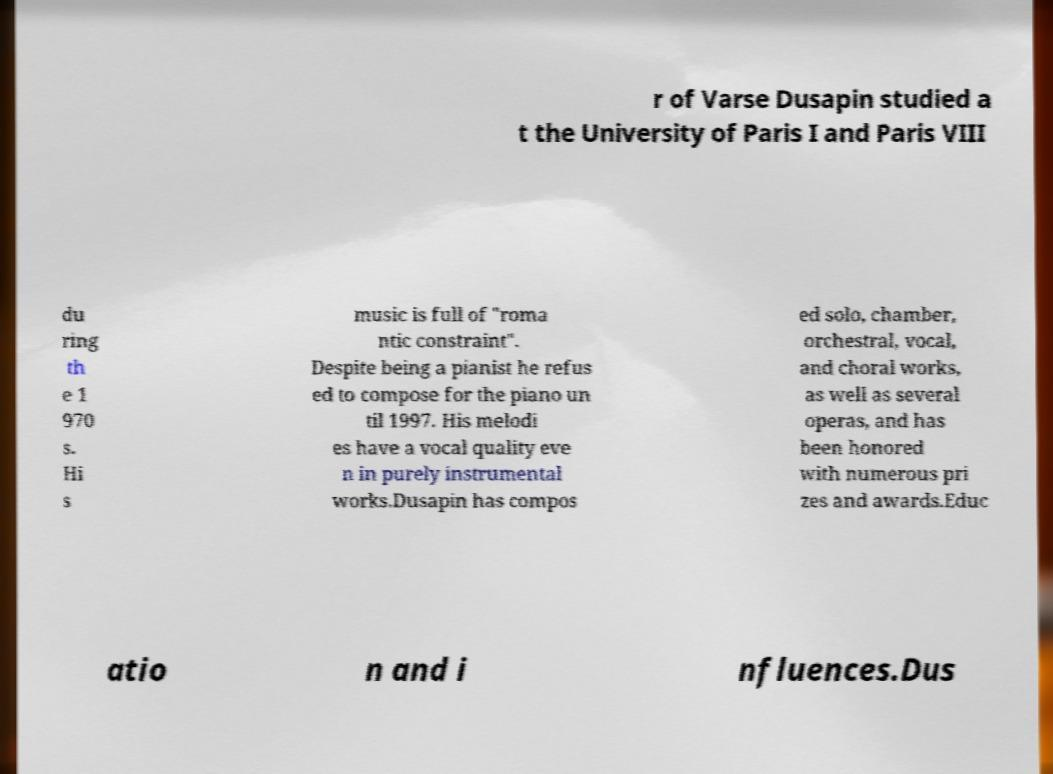Please identify and transcribe the text found in this image. r of Varse Dusapin studied a t the University of Paris I and Paris VIII du ring th e 1 970 s. Hi s music is full of "roma ntic constraint". Despite being a pianist he refus ed to compose for the piano un til 1997. His melodi es have a vocal quality eve n in purely instrumental works.Dusapin has compos ed solo, chamber, orchestral, vocal, and choral works, as well as several operas, and has been honored with numerous pri zes and awards.Educ atio n and i nfluences.Dus 